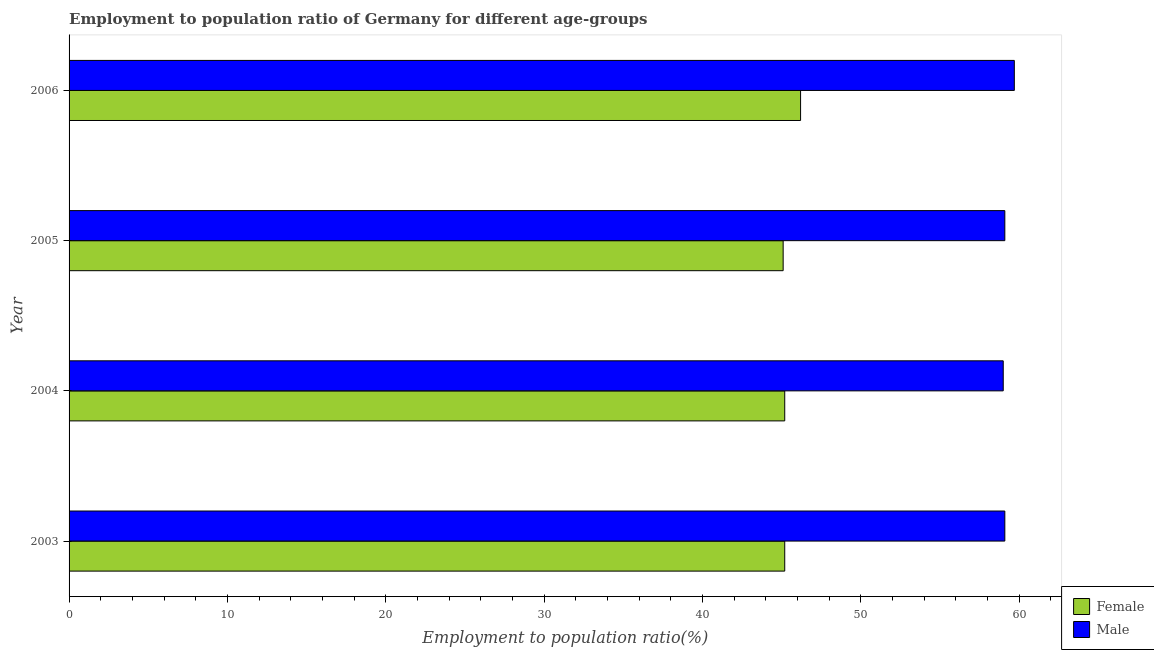How many groups of bars are there?
Your answer should be compact. 4. Are the number of bars per tick equal to the number of legend labels?
Make the answer very short. Yes. What is the label of the 3rd group of bars from the top?
Provide a short and direct response. 2004. In how many cases, is the number of bars for a given year not equal to the number of legend labels?
Make the answer very short. 0. What is the employment to population ratio(male) in 2003?
Offer a terse response. 59.1. Across all years, what is the maximum employment to population ratio(male)?
Your answer should be very brief. 59.7. Across all years, what is the minimum employment to population ratio(female)?
Your response must be concise. 45.1. In which year was the employment to population ratio(male) minimum?
Make the answer very short. 2004. What is the total employment to population ratio(male) in the graph?
Your answer should be very brief. 236.9. What is the difference between the employment to population ratio(male) in 2003 and the employment to population ratio(female) in 2004?
Provide a succinct answer. 13.9. What is the average employment to population ratio(male) per year?
Give a very brief answer. 59.23. In how many years, is the employment to population ratio(male) greater than 58 %?
Your answer should be compact. 4. Is the employment to population ratio(male) in 2003 less than that in 2004?
Ensure brevity in your answer.  No. What is the difference between the highest and the second highest employment to population ratio(male)?
Provide a short and direct response. 0.6. Is the sum of the employment to population ratio(male) in 2003 and 2005 greater than the maximum employment to population ratio(female) across all years?
Keep it short and to the point. Yes. What is the difference between two consecutive major ticks on the X-axis?
Offer a very short reply. 10. Does the graph contain grids?
Provide a succinct answer. No. Where does the legend appear in the graph?
Provide a short and direct response. Bottom right. What is the title of the graph?
Offer a very short reply. Employment to population ratio of Germany for different age-groups. What is the label or title of the X-axis?
Give a very brief answer. Employment to population ratio(%). What is the label or title of the Y-axis?
Provide a short and direct response. Year. What is the Employment to population ratio(%) in Female in 2003?
Provide a short and direct response. 45.2. What is the Employment to population ratio(%) of Male in 2003?
Your answer should be very brief. 59.1. What is the Employment to population ratio(%) in Female in 2004?
Offer a very short reply. 45.2. What is the Employment to population ratio(%) of Male in 2004?
Your answer should be compact. 59. What is the Employment to population ratio(%) in Female in 2005?
Provide a succinct answer. 45.1. What is the Employment to population ratio(%) of Male in 2005?
Your response must be concise. 59.1. What is the Employment to population ratio(%) in Female in 2006?
Offer a very short reply. 46.2. What is the Employment to population ratio(%) of Male in 2006?
Your response must be concise. 59.7. Across all years, what is the maximum Employment to population ratio(%) of Female?
Provide a short and direct response. 46.2. Across all years, what is the maximum Employment to population ratio(%) in Male?
Your response must be concise. 59.7. Across all years, what is the minimum Employment to population ratio(%) of Female?
Your answer should be very brief. 45.1. Across all years, what is the minimum Employment to population ratio(%) in Male?
Make the answer very short. 59. What is the total Employment to population ratio(%) in Female in the graph?
Make the answer very short. 181.7. What is the total Employment to population ratio(%) in Male in the graph?
Offer a very short reply. 236.9. What is the difference between the Employment to population ratio(%) of Female in 2003 and that in 2004?
Provide a succinct answer. 0. What is the difference between the Employment to population ratio(%) of Female in 2004 and that in 2005?
Provide a short and direct response. 0.1. What is the difference between the Employment to population ratio(%) of Male in 2004 and that in 2006?
Offer a very short reply. -0.7. What is the difference between the Employment to population ratio(%) in Female in 2005 and that in 2006?
Your response must be concise. -1.1. What is the difference between the Employment to population ratio(%) in Female in 2003 and the Employment to population ratio(%) in Male in 2004?
Your response must be concise. -13.8. What is the difference between the Employment to population ratio(%) of Female in 2003 and the Employment to population ratio(%) of Male in 2005?
Your answer should be compact. -13.9. What is the difference between the Employment to population ratio(%) in Female in 2003 and the Employment to population ratio(%) in Male in 2006?
Make the answer very short. -14.5. What is the difference between the Employment to population ratio(%) of Female in 2004 and the Employment to population ratio(%) of Male in 2006?
Provide a short and direct response. -14.5. What is the difference between the Employment to population ratio(%) of Female in 2005 and the Employment to population ratio(%) of Male in 2006?
Offer a very short reply. -14.6. What is the average Employment to population ratio(%) in Female per year?
Give a very brief answer. 45.42. What is the average Employment to population ratio(%) of Male per year?
Your answer should be compact. 59.23. In the year 2004, what is the difference between the Employment to population ratio(%) of Female and Employment to population ratio(%) of Male?
Make the answer very short. -13.8. What is the ratio of the Employment to population ratio(%) of Female in 2003 to that in 2004?
Your response must be concise. 1. What is the ratio of the Employment to population ratio(%) in Male in 2003 to that in 2005?
Offer a very short reply. 1. What is the ratio of the Employment to population ratio(%) of Female in 2003 to that in 2006?
Give a very brief answer. 0.98. What is the ratio of the Employment to population ratio(%) in Female in 2004 to that in 2006?
Your response must be concise. 0.98. What is the ratio of the Employment to population ratio(%) in Male in 2004 to that in 2006?
Make the answer very short. 0.99. What is the ratio of the Employment to population ratio(%) of Female in 2005 to that in 2006?
Your answer should be compact. 0.98. What is the difference between the highest and the second highest Employment to population ratio(%) of Male?
Make the answer very short. 0.6. What is the difference between the highest and the lowest Employment to population ratio(%) of Female?
Offer a very short reply. 1.1. 